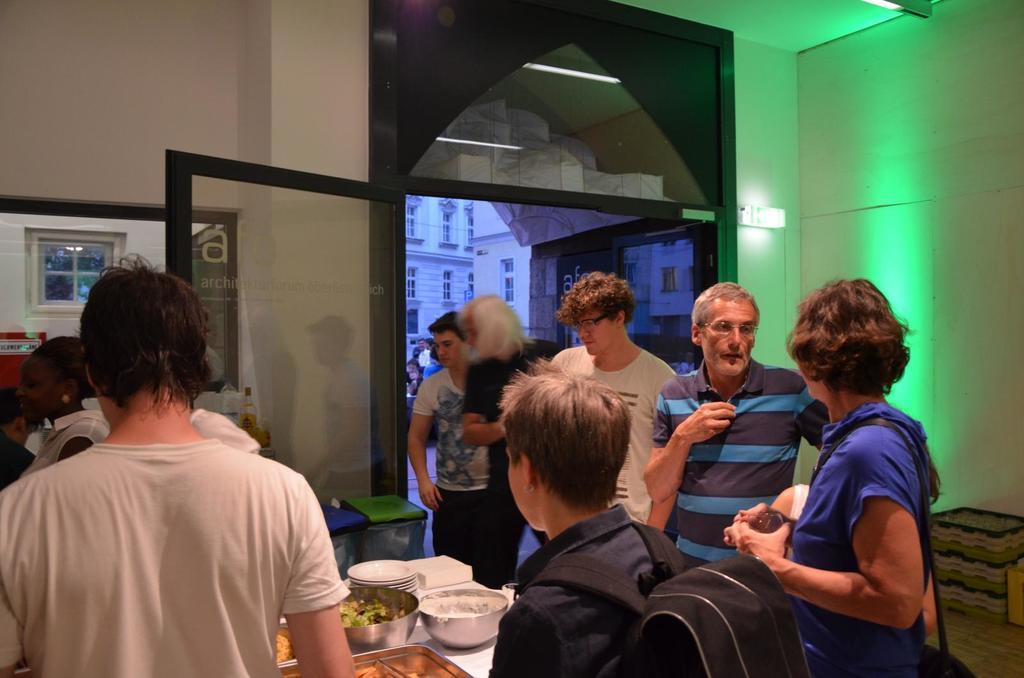How many people are present in the image? There are people standing in the image. Can you describe what one of the people is wearing? One person is wearing a bag. What piece of furniture is visible in the image? There is a table in the image. What is on the table? There is a bowl, food, a plate, and tissues on the table. Is there a snake slithering on the table in the image? No, there is no snake present in the image. Is the person wearing the bag in jail in the image? There is no indication of a jail or any legal situation in the image. 